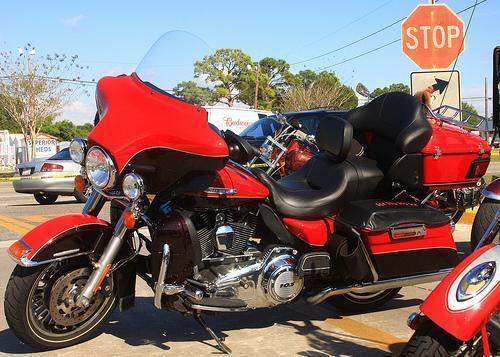How many blue motors are there?
Give a very brief answer. 0. 